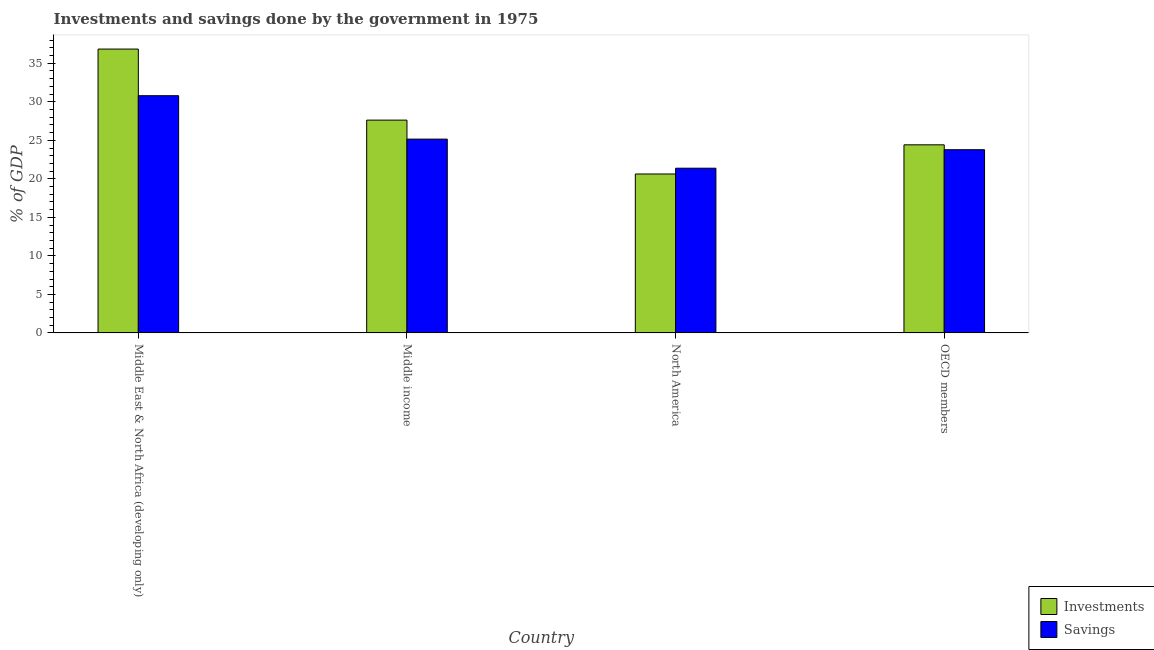Are the number of bars on each tick of the X-axis equal?
Make the answer very short. Yes. How many bars are there on the 1st tick from the right?
Offer a terse response. 2. In how many cases, is the number of bars for a given country not equal to the number of legend labels?
Give a very brief answer. 0. What is the savings of government in OECD members?
Provide a succinct answer. 23.78. Across all countries, what is the maximum savings of government?
Make the answer very short. 30.79. Across all countries, what is the minimum investments of government?
Provide a short and direct response. 20.63. In which country was the investments of government maximum?
Your answer should be compact. Middle East & North Africa (developing only). What is the total savings of government in the graph?
Your answer should be compact. 101.11. What is the difference between the savings of government in Middle East & North Africa (developing only) and that in North America?
Provide a short and direct response. 9.41. What is the difference between the savings of government in OECD members and the investments of government in Middle income?
Provide a short and direct response. -3.84. What is the average investments of government per country?
Make the answer very short. 27.38. What is the difference between the savings of government and investments of government in North America?
Your response must be concise. 0.75. In how many countries, is the investments of government greater than 23 %?
Offer a terse response. 3. What is the ratio of the investments of government in Middle East & North Africa (developing only) to that in North America?
Offer a very short reply. 1.79. Is the difference between the savings of government in Middle East & North Africa (developing only) and Middle income greater than the difference between the investments of government in Middle East & North Africa (developing only) and Middle income?
Your answer should be compact. No. What is the difference between the highest and the second highest savings of government?
Provide a short and direct response. 5.64. What is the difference between the highest and the lowest savings of government?
Give a very brief answer. 9.41. What does the 1st bar from the left in Middle income represents?
Your answer should be compact. Investments. What does the 1st bar from the right in North America represents?
Offer a very short reply. Savings. How many countries are there in the graph?
Offer a terse response. 4. Are the values on the major ticks of Y-axis written in scientific E-notation?
Make the answer very short. No. Does the graph contain any zero values?
Your answer should be very brief. No. How are the legend labels stacked?
Offer a very short reply. Vertical. What is the title of the graph?
Your answer should be very brief. Investments and savings done by the government in 1975. What is the label or title of the X-axis?
Offer a very short reply. Country. What is the label or title of the Y-axis?
Make the answer very short. % of GDP. What is the % of GDP in Investments in Middle East & North Africa (developing only)?
Your answer should be very brief. 36.85. What is the % of GDP of Savings in Middle East & North Africa (developing only)?
Give a very brief answer. 30.79. What is the % of GDP in Investments in Middle income?
Keep it short and to the point. 27.62. What is the % of GDP in Savings in Middle income?
Your answer should be compact. 25.16. What is the % of GDP of Investments in North America?
Your response must be concise. 20.63. What is the % of GDP in Savings in North America?
Offer a very short reply. 21.38. What is the % of GDP in Investments in OECD members?
Provide a short and direct response. 24.42. What is the % of GDP in Savings in OECD members?
Your response must be concise. 23.78. Across all countries, what is the maximum % of GDP of Investments?
Provide a succinct answer. 36.85. Across all countries, what is the maximum % of GDP of Savings?
Provide a short and direct response. 30.79. Across all countries, what is the minimum % of GDP in Investments?
Make the answer very short. 20.63. Across all countries, what is the minimum % of GDP in Savings?
Make the answer very short. 21.38. What is the total % of GDP of Investments in the graph?
Make the answer very short. 109.52. What is the total % of GDP of Savings in the graph?
Your response must be concise. 101.11. What is the difference between the % of GDP in Investments in Middle East & North Africa (developing only) and that in Middle income?
Your answer should be compact. 9.22. What is the difference between the % of GDP in Savings in Middle East & North Africa (developing only) and that in Middle income?
Your answer should be very brief. 5.64. What is the difference between the % of GDP of Investments in Middle East & North Africa (developing only) and that in North America?
Ensure brevity in your answer.  16.21. What is the difference between the % of GDP of Savings in Middle East & North Africa (developing only) and that in North America?
Provide a short and direct response. 9.41. What is the difference between the % of GDP in Investments in Middle East & North Africa (developing only) and that in OECD members?
Keep it short and to the point. 12.43. What is the difference between the % of GDP of Savings in Middle East & North Africa (developing only) and that in OECD members?
Offer a very short reply. 7.01. What is the difference between the % of GDP in Investments in Middle income and that in North America?
Make the answer very short. 6.99. What is the difference between the % of GDP of Savings in Middle income and that in North America?
Offer a terse response. 3.78. What is the difference between the % of GDP in Investments in Middle income and that in OECD members?
Keep it short and to the point. 3.21. What is the difference between the % of GDP in Savings in Middle income and that in OECD members?
Provide a short and direct response. 1.37. What is the difference between the % of GDP of Investments in North America and that in OECD members?
Your response must be concise. -3.79. What is the difference between the % of GDP in Savings in North America and that in OECD members?
Provide a succinct answer. -2.4. What is the difference between the % of GDP of Investments in Middle East & North Africa (developing only) and the % of GDP of Savings in Middle income?
Offer a terse response. 11.69. What is the difference between the % of GDP in Investments in Middle East & North Africa (developing only) and the % of GDP in Savings in North America?
Provide a succinct answer. 15.46. What is the difference between the % of GDP in Investments in Middle East & North Africa (developing only) and the % of GDP in Savings in OECD members?
Keep it short and to the point. 13.06. What is the difference between the % of GDP of Investments in Middle income and the % of GDP of Savings in North America?
Offer a very short reply. 6.24. What is the difference between the % of GDP of Investments in Middle income and the % of GDP of Savings in OECD members?
Ensure brevity in your answer.  3.84. What is the difference between the % of GDP of Investments in North America and the % of GDP of Savings in OECD members?
Ensure brevity in your answer.  -3.15. What is the average % of GDP of Investments per country?
Your answer should be very brief. 27.38. What is the average % of GDP of Savings per country?
Ensure brevity in your answer.  25.28. What is the difference between the % of GDP of Investments and % of GDP of Savings in Middle East & North Africa (developing only)?
Your answer should be compact. 6.05. What is the difference between the % of GDP of Investments and % of GDP of Savings in Middle income?
Provide a succinct answer. 2.47. What is the difference between the % of GDP in Investments and % of GDP in Savings in North America?
Your answer should be compact. -0.75. What is the difference between the % of GDP in Investments and % of GDP in Savings in OECD members?
Provide a succinct answer. 0.63. What is the ratio of the % of GDP in Investments in Middle East & North Africa (developing only) to that in Middle income?
Your answer should be compact. 1.33. What is the ratio of the % of GDP in Savings in Middle East & North Africa (developing only) to that in Middle income?
Offer a terse response. 1.22. What is the ratio of the % of GDP in Investments in Middle East & North Africa (developing only) to that in North America?
Your answer should be very brief. 1.79. What is the ratio of the % of GDP in Savings in Middle East & North Africa (developing only) to that in North America?
Provide a short and direct response. 1.44. What is the ratio of the % of GDP in Investments in Middle East & North Africa (developing only) to that in OECD members?
Ensure brevity in your answer.  1.51. What is the ratio of the % of GDP of Savings in Middle East & North Africa (developing only) to that in OECD members?
Keep it short and to the point. 1.29. What is the ratio of the % of GDP in Investments in Middle income to that in North America?
Your answer should be very brief. 1.34. What is the ratio of the % of GDP in Savings in Middle income to that in North America?
Ensure brevity in your answer.  1.18. What is the ratio of the % of GDP of Investments in Middle income to that in OECD members?
Provide a succinct answer. 1.13. What is the ratio of the % of GDP of Savings in Middle income to that in OECD members?
Your answer should be very brief. 1.06. What is the ratio of the % of GDP of Investments in North America to that in OECD members?
Keep it short and to the point. 0.84. What is the ratio of the % of GDP of Savings in North America to that in OECD members?
Make the answer very short. 0.9. What is the difference between the highest and the second highest % of GDP in Investments?
Offer a very short reply. 9.22. What is the difference between the highest and the second highest % of GDP in Savings?
Provide a short and direct response. 5.64. What is the difference between the highest and the lowest % of GDP in Investments?
Offer a terse response. 16.21. What is the difference between the highest and the lowest % of GDP of Savings?
Your answer should be compact. 9.41. 